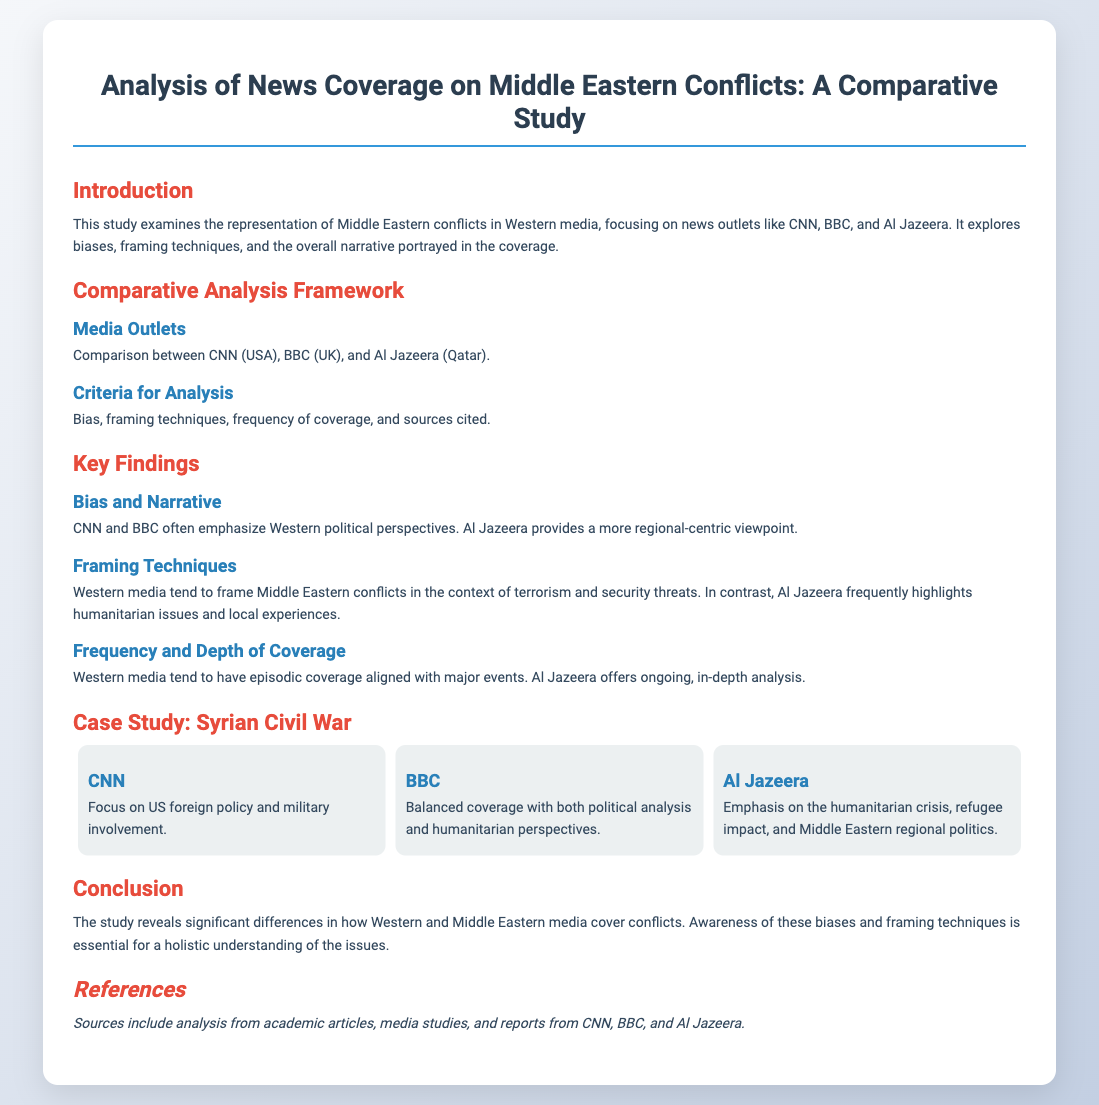What are the main media outlets compared in the study? The study compares CNN, BBC, and Al Jazeera as the main media outlets focusing on Middle Eastern conflicts.
Answer: CNN, BBC, Al Jazeera What framing technique is often used by Western media? The document states that Western media often frame Middle Eastern conflicts in relation to terrorism and security threats.
Answer: Terrorism and security threats Which media outlet provides a regional-centric viewpoint? Al Jazeera is noted for providing a more regional-centric viewpoint in its coverage of Middle Eastern conflicts.
Answer: Al Jazeera What is the focus of CNN's coverage of the Syrian Civil War? CNN focuses on US foreign policy and military involvement during its coverage of the Syrian Civil War.
Answer: US foreign policy and military involvement What aspect of the conflict does Al Jazeera emphasize? Al Jazeera is noted for emphasizing the humanitarian crisis and refugee impact in its coverage.
Answer: Humanitarian crisis and refugee impact How does BBC's coverage approach the Syrian Civil War? The BBC offers balanced coverage that includes both political analysis and humanitarian perspectives related to the Syrian Civil War.
Answer: Balanced coverage What criteria were used for the comparative analysis? The criteria for analysis include bias, framing techniques, frequency of coverage, and sources cited.
Answer: Bias, framing techniques, frequency of coverage, sources cited What does the conclusion highlight regarding Western and Middle Eastern media? The conclusion highlights the significant differences in how Western and Middle Eastern media cover conflicts, emphasizing awareness of biases and framing techniques.
Answer: Significant differences in coverage In what type of document is this information presented? The format of the document is a presentation slide, which is used to convey the analysis of news coverage.
Answer: Presentation slide 